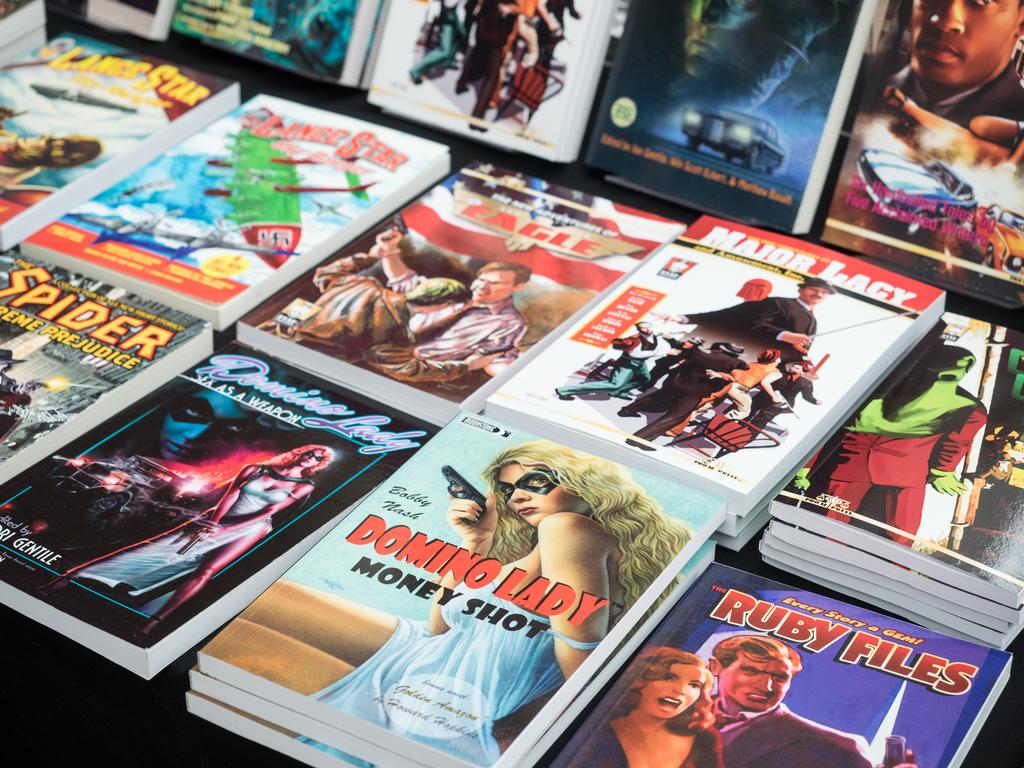<image>
Summarize the visual content of the image. A tabletop full of paperback books displays titles including The Ruby Files, Major Lacy and Domino Lady Money Shot. 